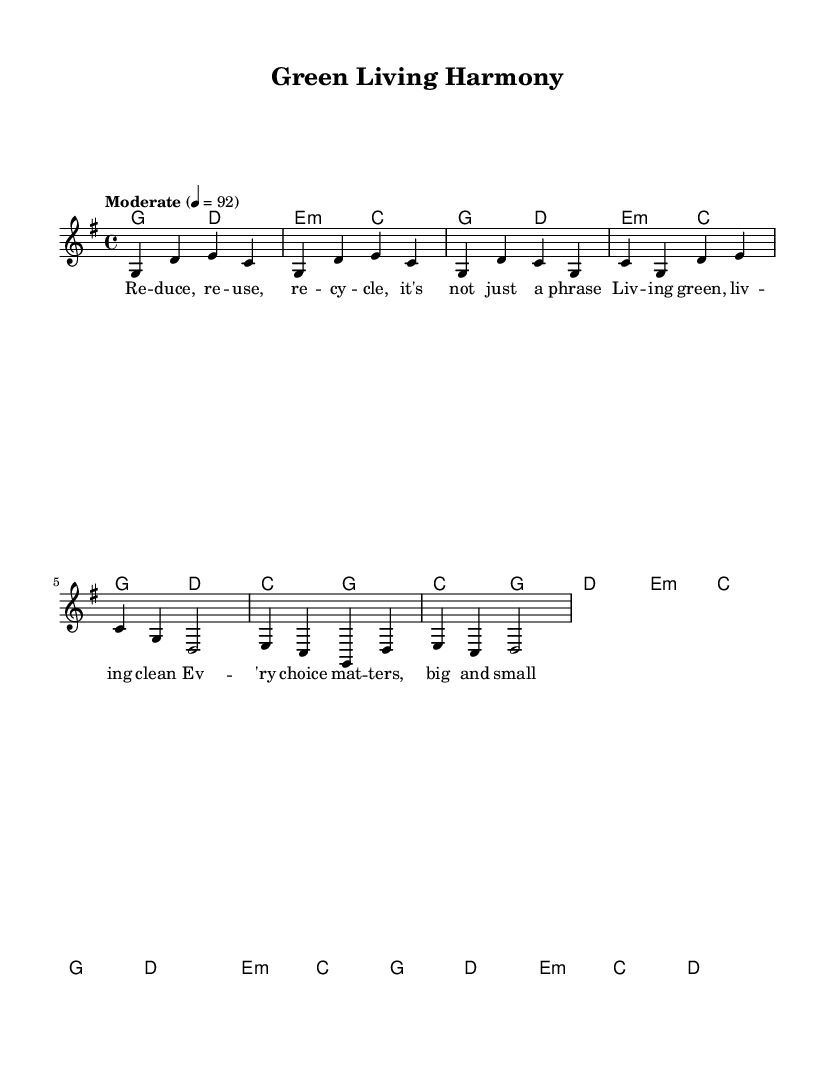What is the key signature of this music? The key signature is G major, which has one sharp (F#). This is indicated by the presence of one sharp in the key signature at the beginning of the sheet music.
Answer: G major What is the time signature of this music? The time signature is 4/4, as shown at the beginning of the sheet music. This means there are four beats in each measure and the quarter note gets one beat.
Answer: 4/4 What is the tempo marking for this piece? The tempo marking is "Moderate" at a speed of 92 beats per minute, which is indicated at the beginning of the score.
Answer: Moderate, 92 How many measures are in the chorus section? The chorus section consists of four measures. These can be identified by looking specifically at the section labeled as Chorus, counting the measures that follow.
Answer: 4 In the bridge, which chords are used? The bridge uses the chords E minor, C, G, and D. This can be determined by examining the chord symbols that accompany the melody in the Bridge section.
Answer: E minor, C, G, D What is the primary theme of the lyrics in this song? The primary theme of the lyrics is about living sustainably and making environmentally friendly choices. This can be understood by interpreting the words that emphasize reducing, reusing, recycling, and living green.
Answer: Sustainability 